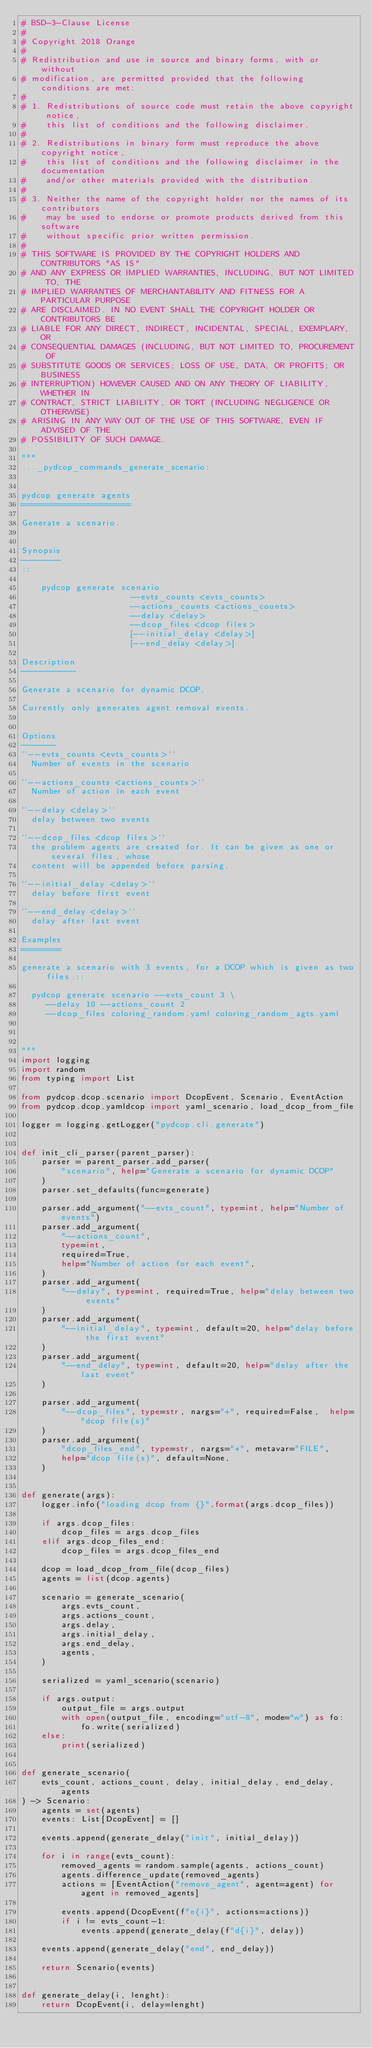<code> <loc_0><loc_0><loc_500><loc_500><_Python_># BSD-3-Clause License
#
# Copyright 2018 Orange
#
# Redistribution and use in source and binary forms, with or without
# modification, are permitted provided that the following conditions are met:
#
# 1. Redistributions of source code must retain the above copyright notice,
#    this list of conditions and the following disclaimer.
#
# 2. Redistributions in binary form must reproduce the above copyright notice,
#    this list of conditions and the following disclaimer in the documentation
#    and/or other materials provided with the distribution.
#
# 3. Neither the name of the copyright holder nor the names of its contributors
#    may be used to endorse or promote products derived from this software
#    without specific prior written permission.
#
# THIS SOFTWARE IS PROVIDED BY THE COPYRIGHT HOLDERS AND CONTRIBUTORS "AS IS"
# AND ANY EXPRESS OR IMPLIED WARRANTIES, INCLUDING, BUT NOT LIMITED TO, THE
# IMPLIED WARRANTIES OF MERCHANTABILITY AND FITNESS FOR A PARTICULAR PURPOSE
# ARE DISCLAIMED. IN NO EVENT SHALL THE COPYRIGHT HOLDER OR CONTRIBUTORS BE
# LIABLE FOR ANY DIRECT, INDIRECT, INCIDENTAL, SPECIAL, EXEMPLARY, OR
# CONSEQUENTIAL DAMAGES (INCLUDING, BUT NOT LIMITED TO, PROCUREMENT OF
# SUBSTITUTE GOODS OR SERVICES; LOSS OF USE, DATA, OR PROFITS; OR BUSINESS
# INTERRUPTION) HOWEVER CAUSED AND ON ANY THEORY OF LIABILITY, WHETHER IN
# CONTRACT, STRICT LIABILITY, OR TORT (INCLUDING NEGLIGENCE OR OTHERWISE)
# ARISING IN ANY WAY OUT OF THE USE OF THIS SOFTWARE, EVEN IF ADVISED OF THE
# POSSIBILITY OF SUCH DAMAGE.

"""
.. _pydcop_commands_generate_scenario:


pydcop generate agents
======================

Generate a scenario.


Synopsis
--------
::

    pydcop generate scenario
                      --evts_counts <evts_counts>
                      --actions_counts <actions_counts>
                      --delay <delay>
                      --dcop_files <dcop files>
                      [--initial_delay <delay>]
                      [--end_delay <delay>]

Description
-----------

Generate a scenario for dynamic DCOP.

Currently only generates agent removal events.


Options
-------
``--evts_counts <evts_counts>``
  Number of events in the scenario

``--actions_counts <actions_counts>``
  Number of action in each event

``--delay <delay>``
  delay between two events

``--dcop_files <dcop files>``
  the problem agents are created for. It can be given as one or several files, whose
  content will be appended before parsing.

``--initial_delay <delay>``
  delay before first event

``--end_delay <delay>``
  delay after last event

Examples
========

generate a scenario with 3 events, for a DCOP which is given as two files.::

  pydcop generate scenario --evts_count 3 \
     --delay 10 --actions_count 2
     --dcop_files coloring_random.yaml coloring_random_agts.yaml



"""
import logging
import random
from typing import List

from pydcop.dcop.scenario import DcopEvent, Scenario, EventAction
from pydcop.dcop.yamldcop import yaml_scenario, load_dcop_from_file

logger = logging.getLogger("pydcop.cli.generate")


def init_cli_parser(parent_parser):
    parser = parent_parser.add_parser(
        "scenario", help="Generate a scenario for dynamic DCOP"
    )
    parser.set_defaults(func=generate)

    parser.add_argument("--evts_count", type=int, help="Number of events")
    parser.add_argument(
        "--actions_count",
        type=int,
        required=True,
        help="Number of action for each event",
    )
    parser.add_argument(
        "--delay", type=int, required=True, help="delay between two events"
    )
    parser.add_argument(
        "--initial_delay", type=int, default=20, help="delay before the first event"
    )
    parser.add_argument(
        "--end_delay", type=int, default=20, help="delay after the last event"
    )

    parser.add_argument(
        "--dcop_files", type=str, nargs="+", required=False,  help="dcop file(s)"
    )
    parser.add_argument(
        "dcop_files_end", type=str, nargs="*", metavar="FILE",
        help="dcop file(s)", default=None,
    )


def generate(args):
    logger.info("loading dcop from {}".format(args.dcop_files))

    if args.dcop_files:
        dcop_files = args.dcop_files
    elif args.dcop_files_end:
        dcop_files = args.dcop_files_end

    dcop = load_dcop_from_file(dcop_files)
    agents = list(dcop.agents)

    scenario = generate_scenario(
        args.evts_count,
        args.actions_count,
        args.delay,
        args.initial_delay,
        args.end_delay,
        agents,
    )

    serialized = yaml_scenario(scenario)

    if args.output:
        output_file = args.output
        with open(output_file, encoding="utf-8", mode="w") as fo:
            fo.write(serialized)
    else:
        print(serialized)


def generate_scenario(
    evts_count, actions_count, delay, initial_delay, end_delay, agents
) -> Scenario:
    agents = set(agents)
    events: List[DcopEvent] = []

    events.append(generate_delay("init", initial_delay))

    for i in range(evts_count):
        removed_agents = random.sample(agents, actions_count)
        agents.difference_update(removed_agents)
        actions = [EventAction("remove_agent", agent=agent) for agent in removed_agents]

        events.append(DcopEvent(f"e{i}", actions=actions))
        if i != evts_count-1:
            events.append(generate_delay(f"d{i}", delay))

    events.append(generate_delay("end", end_delay))

    return Scenario(events)


def generate_delay(i, lenght):
    return DcopEvent(i, delay=lenght)
</code> 